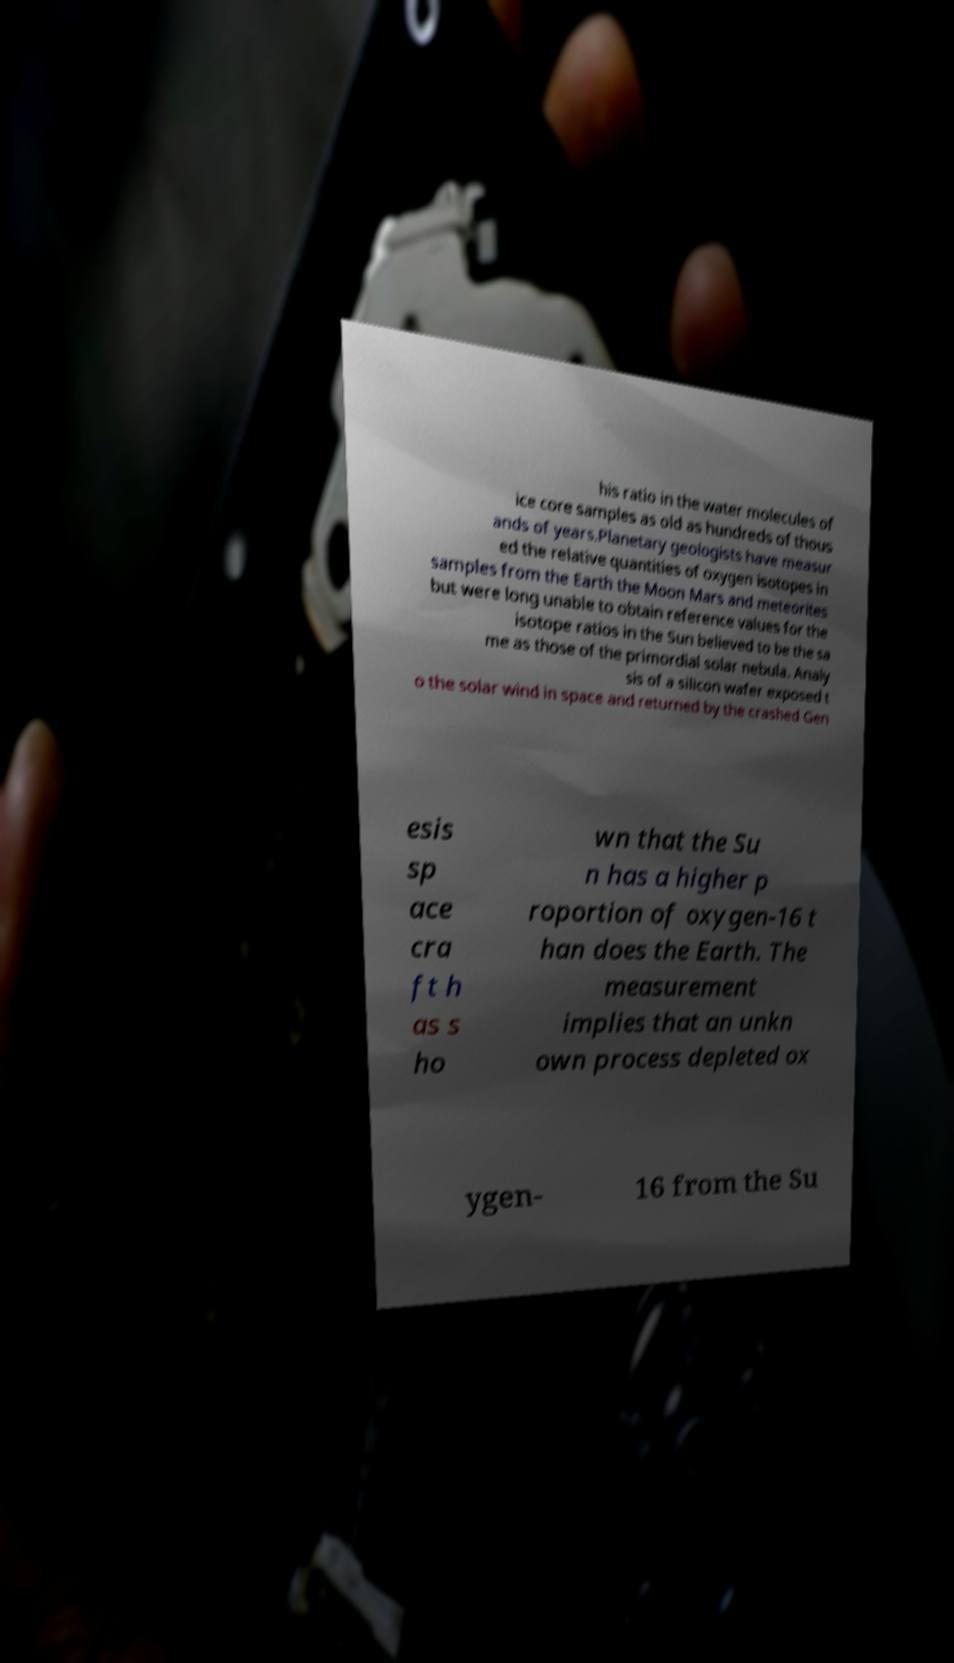Could you assist in decoding the text presented in this image and type it out clearly? his ratio in the water molecules of ice core samples as old as hundreds of thous ands of years.Planetary geologists have measur ed the relative quantities of oxygen isotopes in samples from the Earth the Moon Mars and meteorites but were long unable to obtain reference values for the isotope ratios in the Sun believed to be the sa me as those of the primordial solar nebula. Analy sis of a silicon wafer exposed t o the solar wind in space and returned by the crashed Gen esis sp ace cra ft h as s ho wn that the Su n has a higher p roportion of oxygen-16 t han does the Earth. The measurement implies that an unkn own process depleted ox ygen- 16 from the Su 